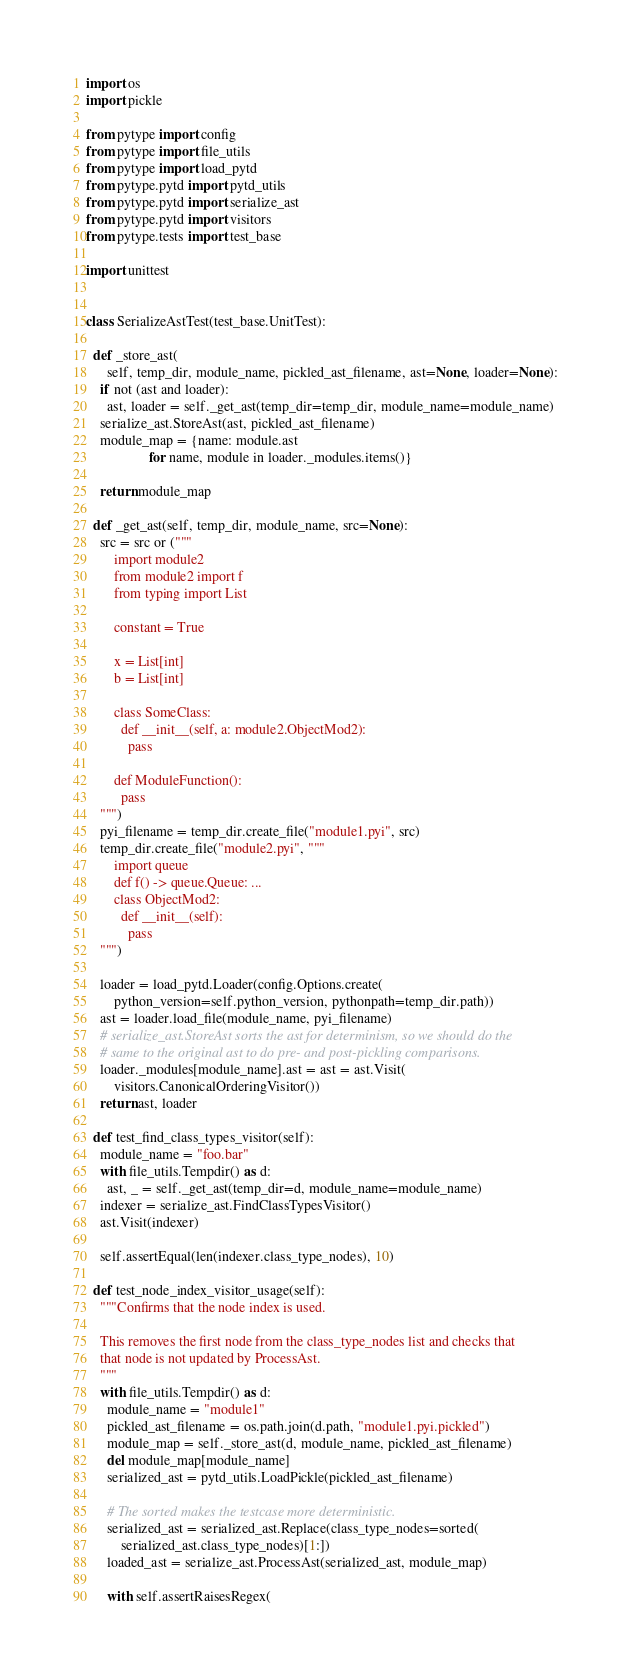<code> <loc_0><loc_0><loc_500><loc_500><_Python_>import os
import pickle

from pytype import config
from pytype import file_utils
from pytype import load_pytd
from pytype.pytd import pytd_utils
from pytype.pytd import serialize_ast
from pytype.pytd import visitors
from pytype.tests import test_base

import unittest


class SerializeAstTest(test_base.UnitTest):

  def _store_ast(
      self, temp_dir, module_name, pickled_ast_filename, ast=None, loader=None):
    if not (ast and loader):
      ast, loader = self._get_ast(temp_dir=temp_dir, module_name=module_name)
    serialize_ast.StoreAst(ast, pickled_ast_filename)
    module_map = {name: module.ast
                  for name, module in loader._modules.items()}

    return module_map

  def _get_ast(self, temp_dir, module_name, src=None):
    src = src or ("""
        import module2
        from module2 import f
        from typing import List

        constant = True

        x = List[int]
        b = List[int]

        class SomeClass:
          def __init__(self, a: module2.ObjectMod2):
            pass

        def ModuleFunction():
          pass
    """)
    pyi_filename = temp_dir.create_file("module1.pyi", src)
    temp_dir.create_file("module2.pyi", """
        import queue
        def f() -> queue.Queue: ...
        class ObjectMod2:
          def __init__(self):
            pass
    """)

    loader = load_pytd.Loader(config.Options.create(
        python_version=self.python_version, pythonpath=temp_dir.path))
    ast = loader.load_file(module_name, pyi_filename)
    # serialize_ast.StoreAst sorts the ast for determinism, so we should do the
    # same to the original ast to do pre- and post-pickling comparisons.
    loader._modules[module_name].ast = ast = ast.Visit(
        visitors.CanonicalOrderingVisitor())
    return ast, loader

  def test_find_class_types_visitor(self):
    module_name = "foo.bar"
    with file_utils.Tempdir() as d:
      ast, _ = self._get_ast(temp_dir=d, module_name=module_name)
    indexer = serialize_ast.FindClassTypesVisitor()
    ast.Visit(indexer)

    self.assertEqual(len(indexer.class_type_nodes), 10)

  def test_node_index_visitor_usage(self):
    """Confirms that the node index is used.

    This removes the first node from the class_type_nodes list and checks that
    that node is not updated by ProcessAst.
    """
    with file_utils.Tempdir() as d:
      module_name = "module1"
      pickled_ast_filename = os.path.join(d.path, "module1.pyi.pickled")
      module_map = self._store_ast(d, module_name, pickled_ast_filename)
      del module_map[module_name]
      serialized_ast = pytd_utils.LoadPickle(pickled_ast_filename)

      # The sorted makes the testcase more deterministic.
      serialized_ast = serialized_ast.Replace(class_type_nodes=sorted(
          serialized_ast.class_type_nodes)[1:])
      loaded_ast = serialize_ast.ProcessAst(serialized_ast, module_map)

      with self.assertRaisesRegex(</code> 